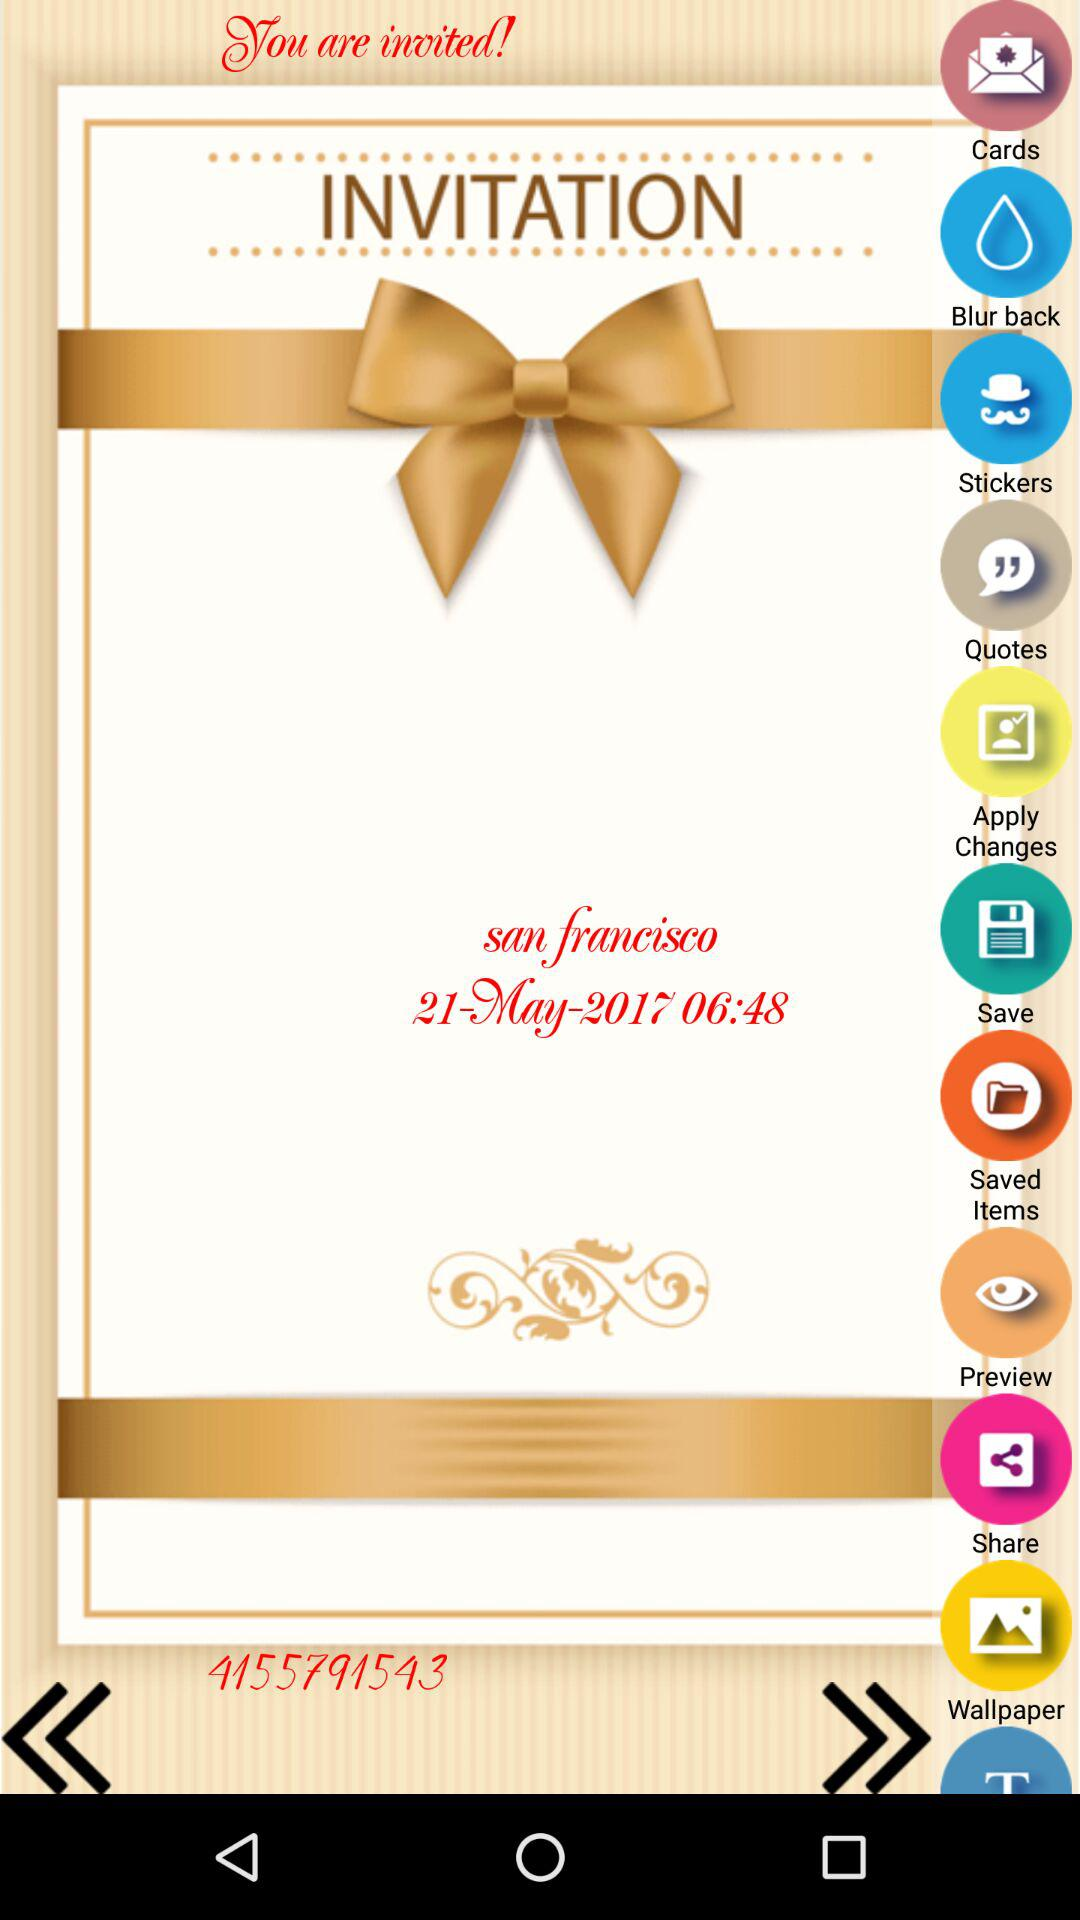The function is scheduled for what date? The function is scheduled for May 21, 2017. 